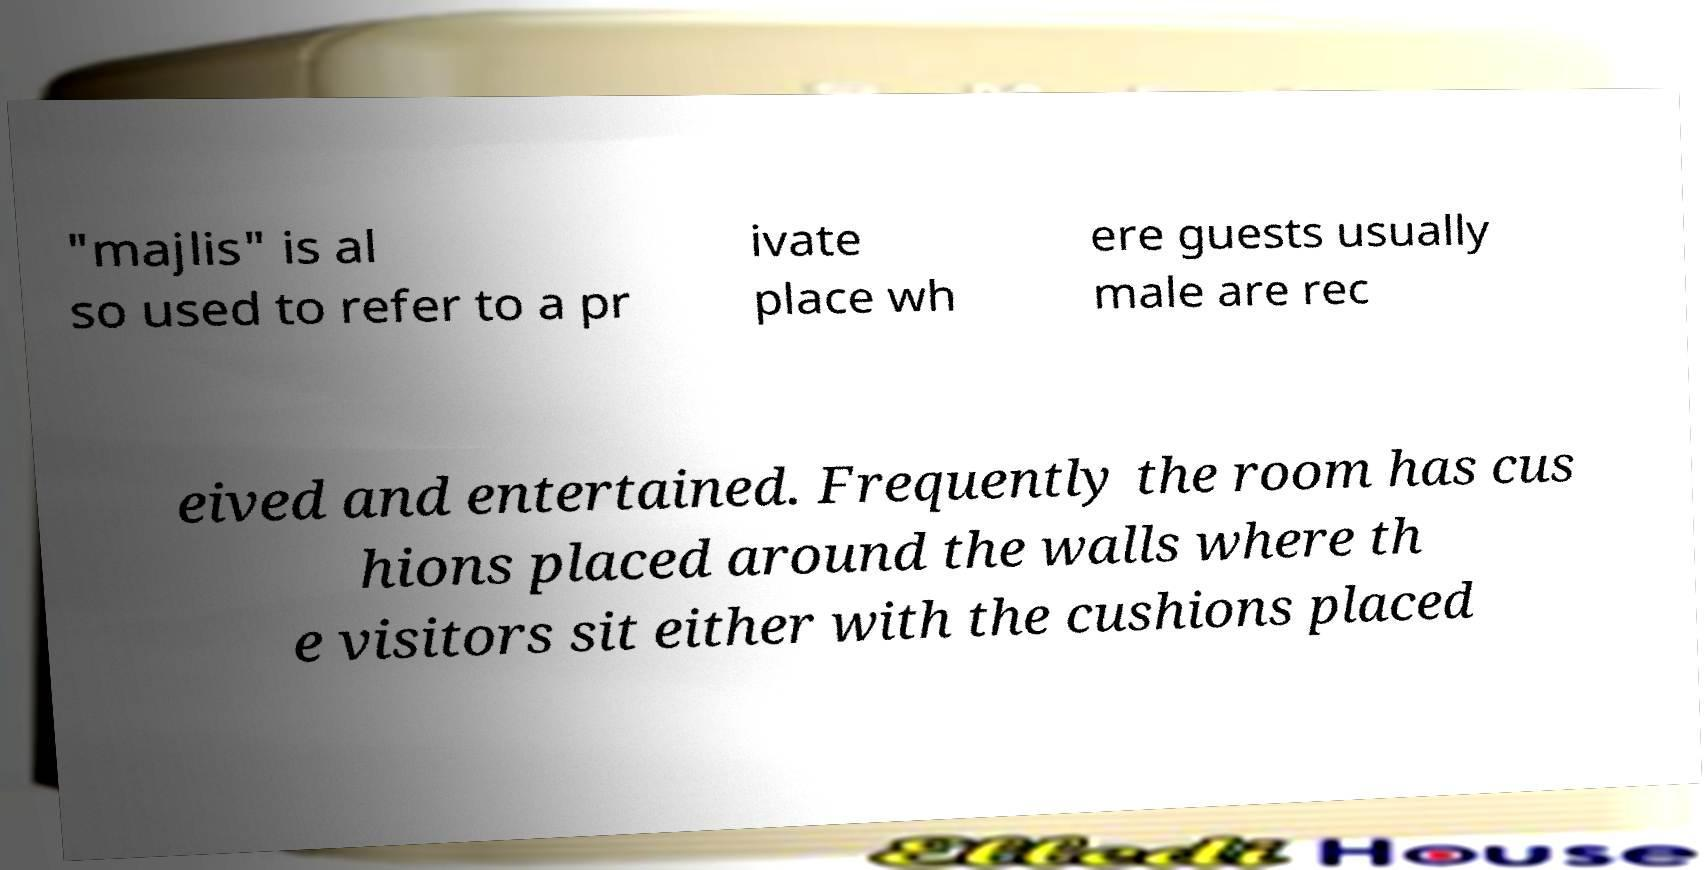Can you read and provide the text displayed in the image?This photo seems to have some interesting text. Can you extract and type it out for me? "majlis" is al so used to refer to a pr ivate place wh ere guests usually male are rec eived and entertained. Frequently the room has cus hions placed around the walls where th e visitors sit either with the cushions placed 